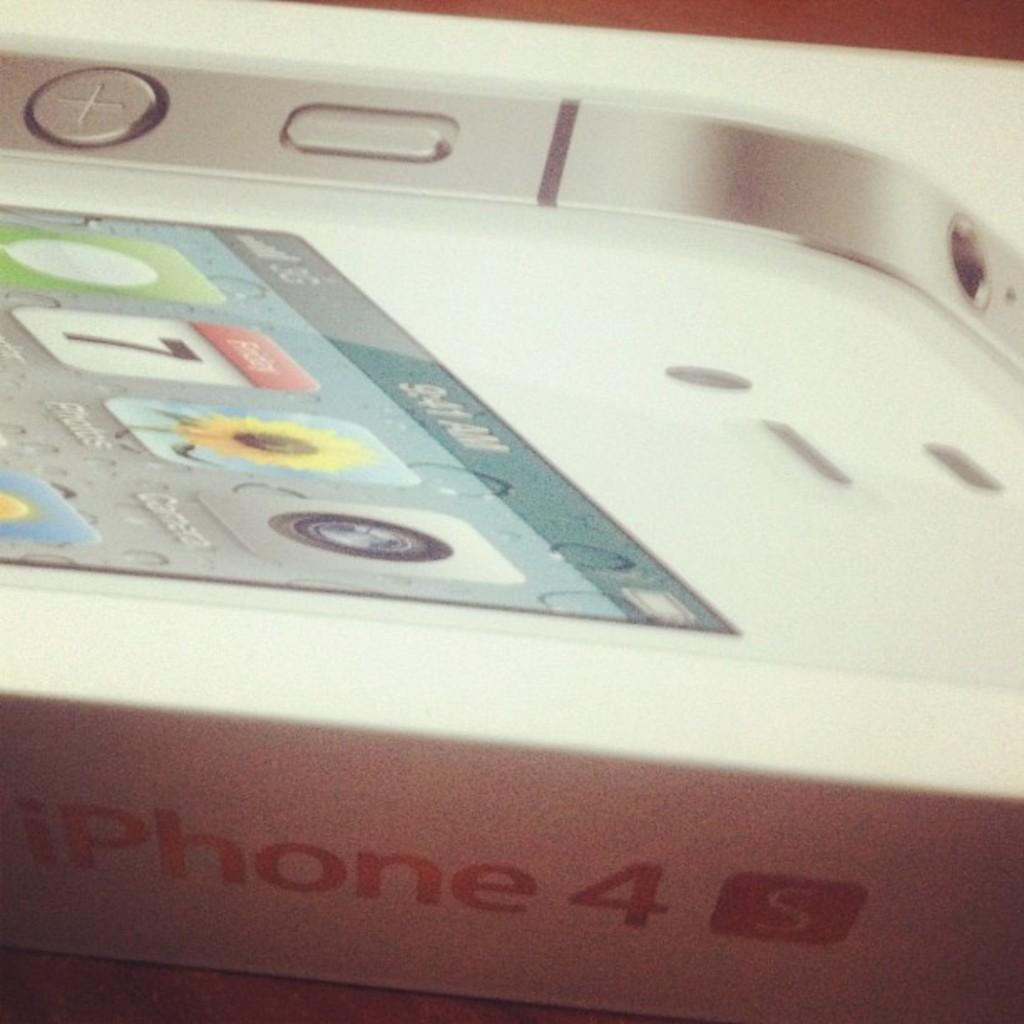<image>
Write a terse but informative summary of the picture. An iPhone4 sits in a white box, which shows that it is the S model. 